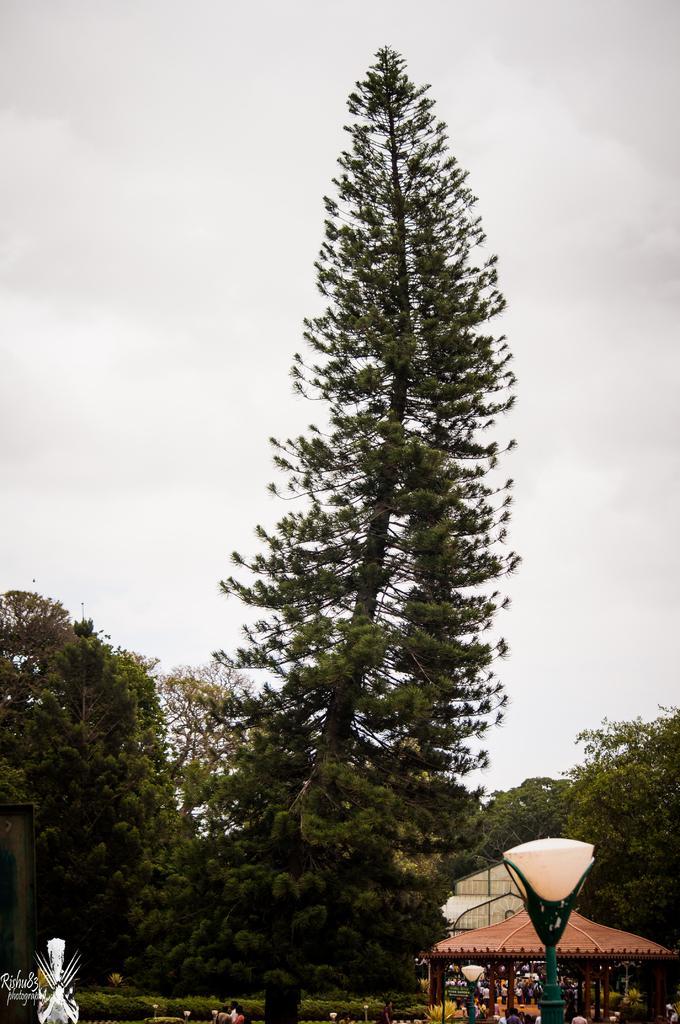Could you give a brief overview of what you see in this image? In this image there are trees and their tents. In the front, there is a pole and the sky is cloudy. 